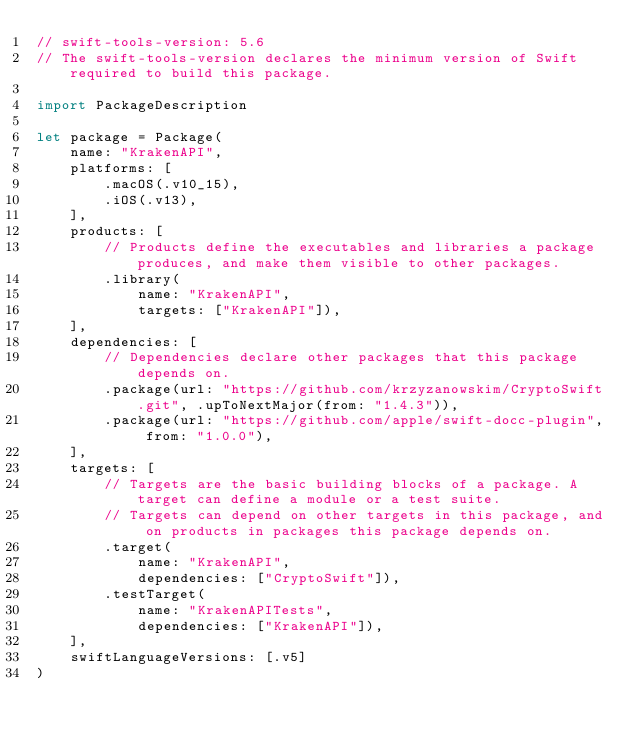<code> <loc_0><loc_0><loc_500><loc_500><_Swift_>// swift-tools-version: 5.6
// The swift-tools-version declares the minimum version of Swift required to build this package.

import PackageDescription

let package = Package(
    name: "KrakenAPI",
    platforms: [
        .macOS(.v10_15),
		.iOS(.v13),
    ],
    products: [
        // Products define the executables and libraries a package produces, and make them visible to other packages.
        .library(
            name: "KrakenAPI",
            targets: ["KrakenAPI"]),
    ],
    dependencies: [
        // Dependencies declare other packages that this package depends on.
        .package(url: "https://github.com/krzyzanowskim/CryptoSwift.git", .upToNextMajor(from: "1.4.3")),
		.package(url: "https://github.com/apple/swift-docc-plugin", from: "1.0.0"),
    ],
    targets: [
        // Targets are the basic building blocks of a package. A target can define a module or a test suite.
        // Targets can depend on other targets in this package, and on products in packages this package depends on.
        .target(
            name: "KrakenAPI",
            dependencies: ["CryptoSwift"]),
        .testTarget(
            name: "KrakenAPITests",
            dependencies: ["KrakenAPI"]),
    ],
	swiftLanguageVersions: [.v5]
)
</code> 